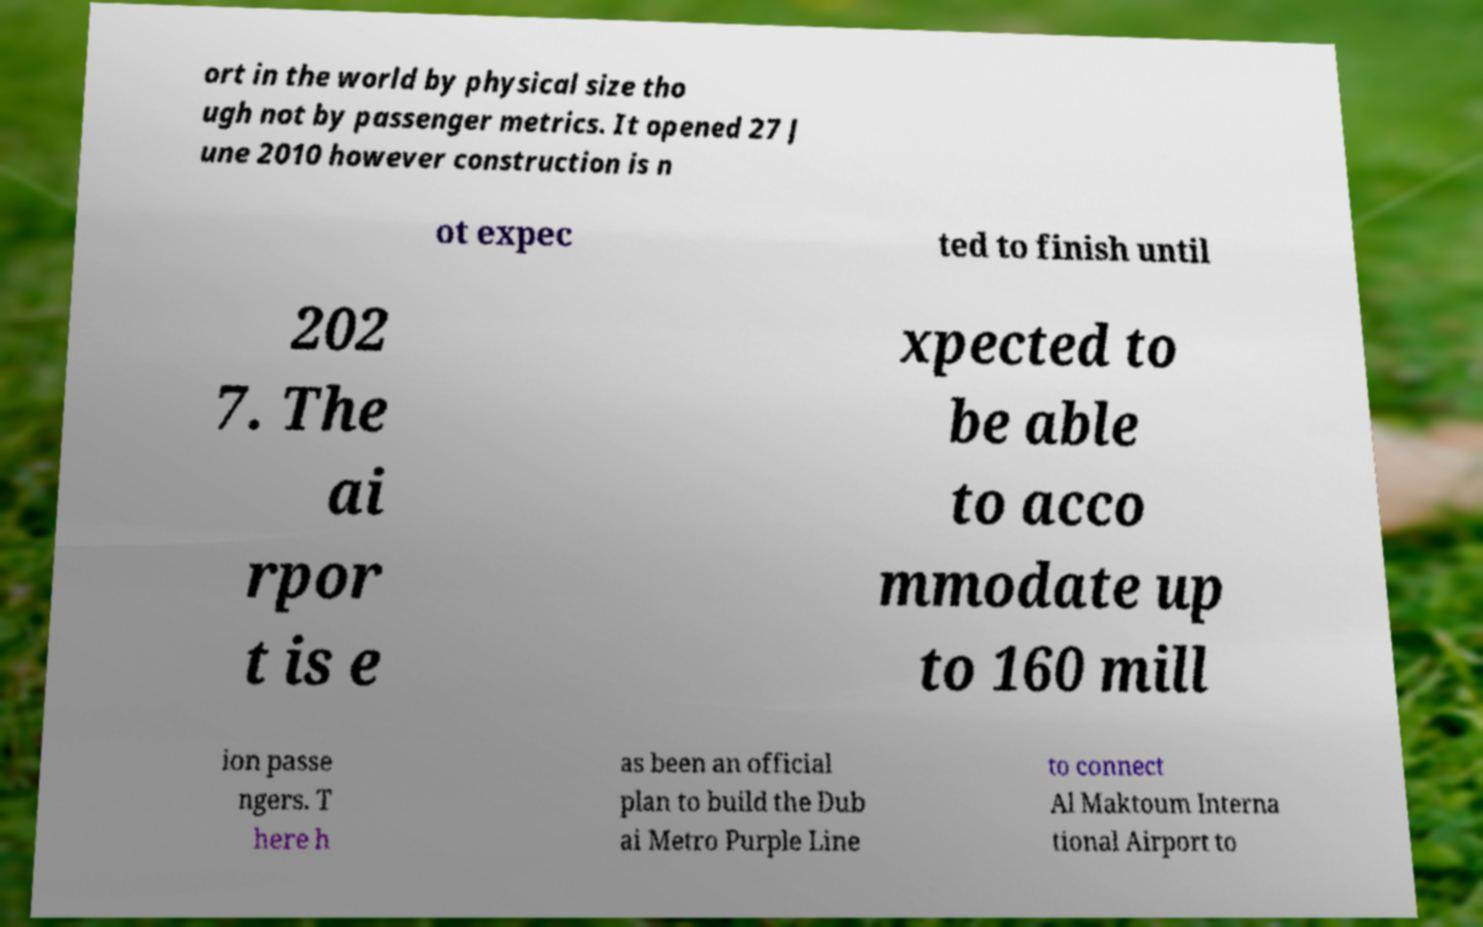Can you accurately transcribe the text from the provided image for me? ort in the world by physical size tho ugh not by passenger metrics. It opened 27 J une 2010 however construction is n ot expec ted to finish until 202 7. The ai rpor t is e xpected to be able to acco mmodate up to 160 mill ion passe ngers. T here h as been an official plan to build the Dub ai Metro Purple Line to connect Al Maktoum Interna tional Airport to 